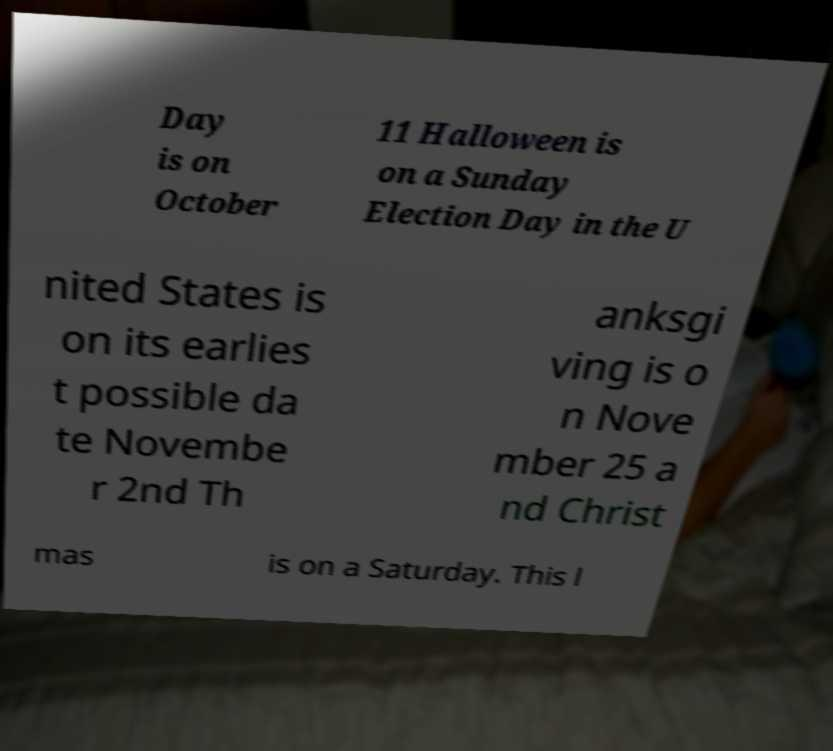Please read and relay the text visible in this image. What does it say? Day is on October 11 Halloween is on a Sunday Election Day in the U nited States is on its earlies t possible da te Novembe r 2nd Th anksgi ving is o n Nove mber 25 a nd Christ mas is on a Saturday. This l 